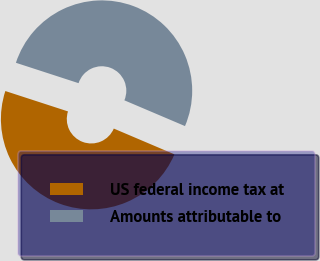Convert chart to OTSL. <chart><loc_0><loc_0><loc_500><loc_500><pie_chart><fcel>US federal income tax at<fcel>Amounts attributable to<nl><fcel>48.61%<fcel>51.39%<nl></chart> 